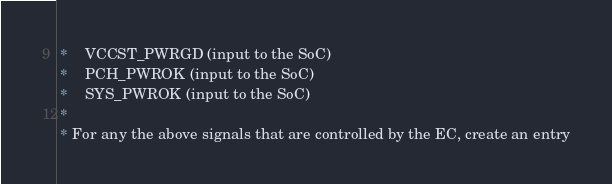<code> <loc_0><loc_0><loc_500><loc_500><_C_> *	VCCST_PWRGD (input to the SoC)
 *	PCH_PWROK (input to the SoC)
 *	SYS_PWROK (input to the SoC)
 *
 * For any the above signals that are controlled by the EC, create an entry</code> 